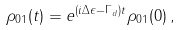<formula> <loc_0><loc_0><loc_500><loc_500>\rho _ { 0 1 } ( t ) = e ^ { ( i \Delta \epsilon - \Gamma _ { d } ) t } \rho _ { 0 1 } ( 0 ) \, ,</formula> 